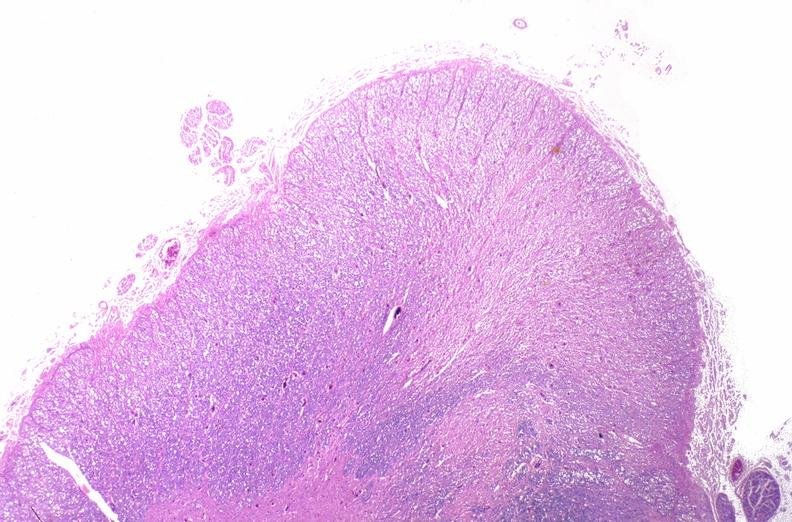s nervous present?
Answer the question using a single word or phrase. Yes 